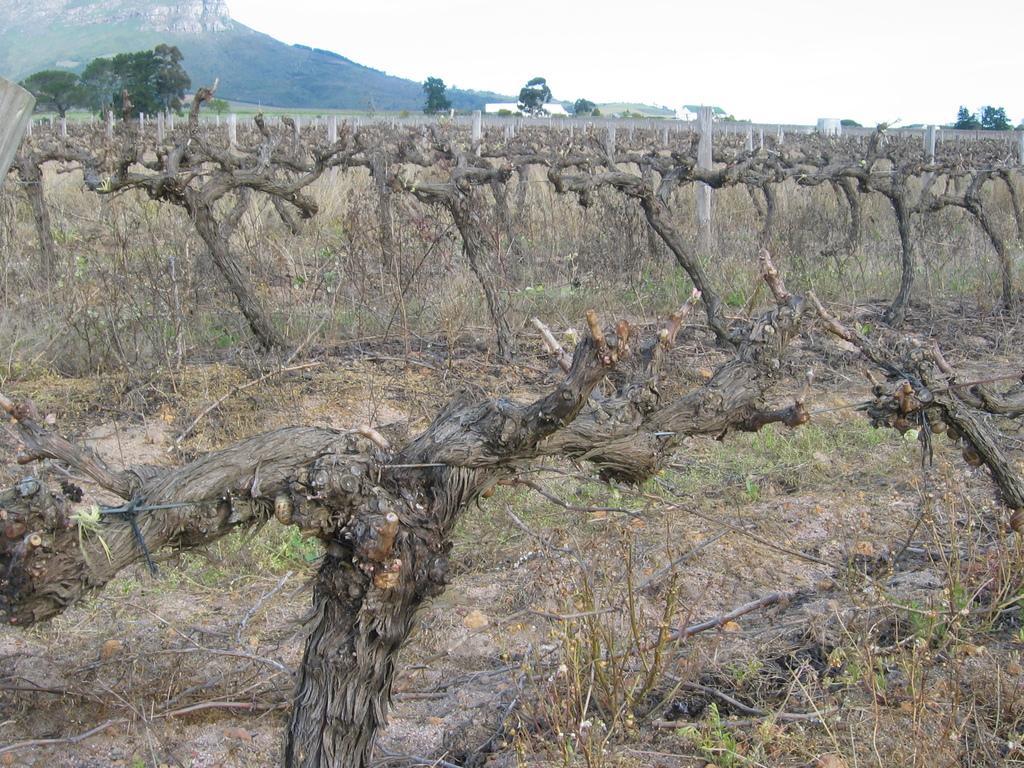Could you give a brief overview of what you see in this image? In this image I can see few trees, dry trees, poles, mountain, sky and few sticks on the ground. 